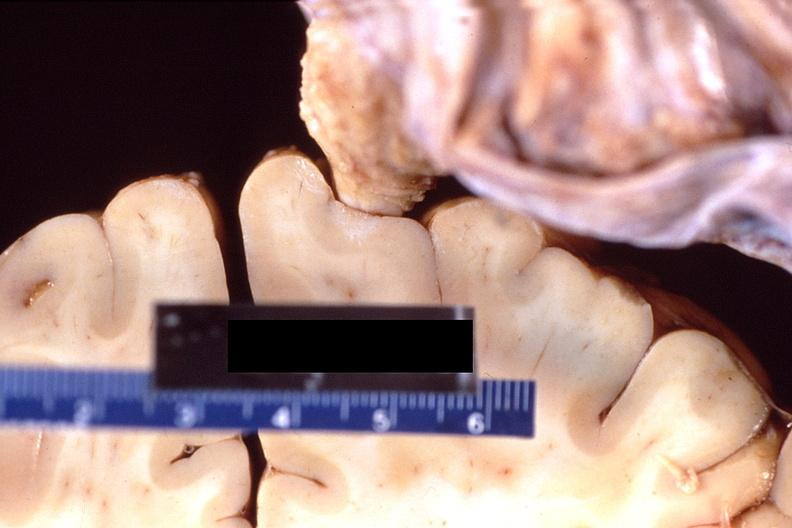does fallopian tube show brain, breast cancer metastasis to meninges?
Answer the question using a single word or phrase. No 